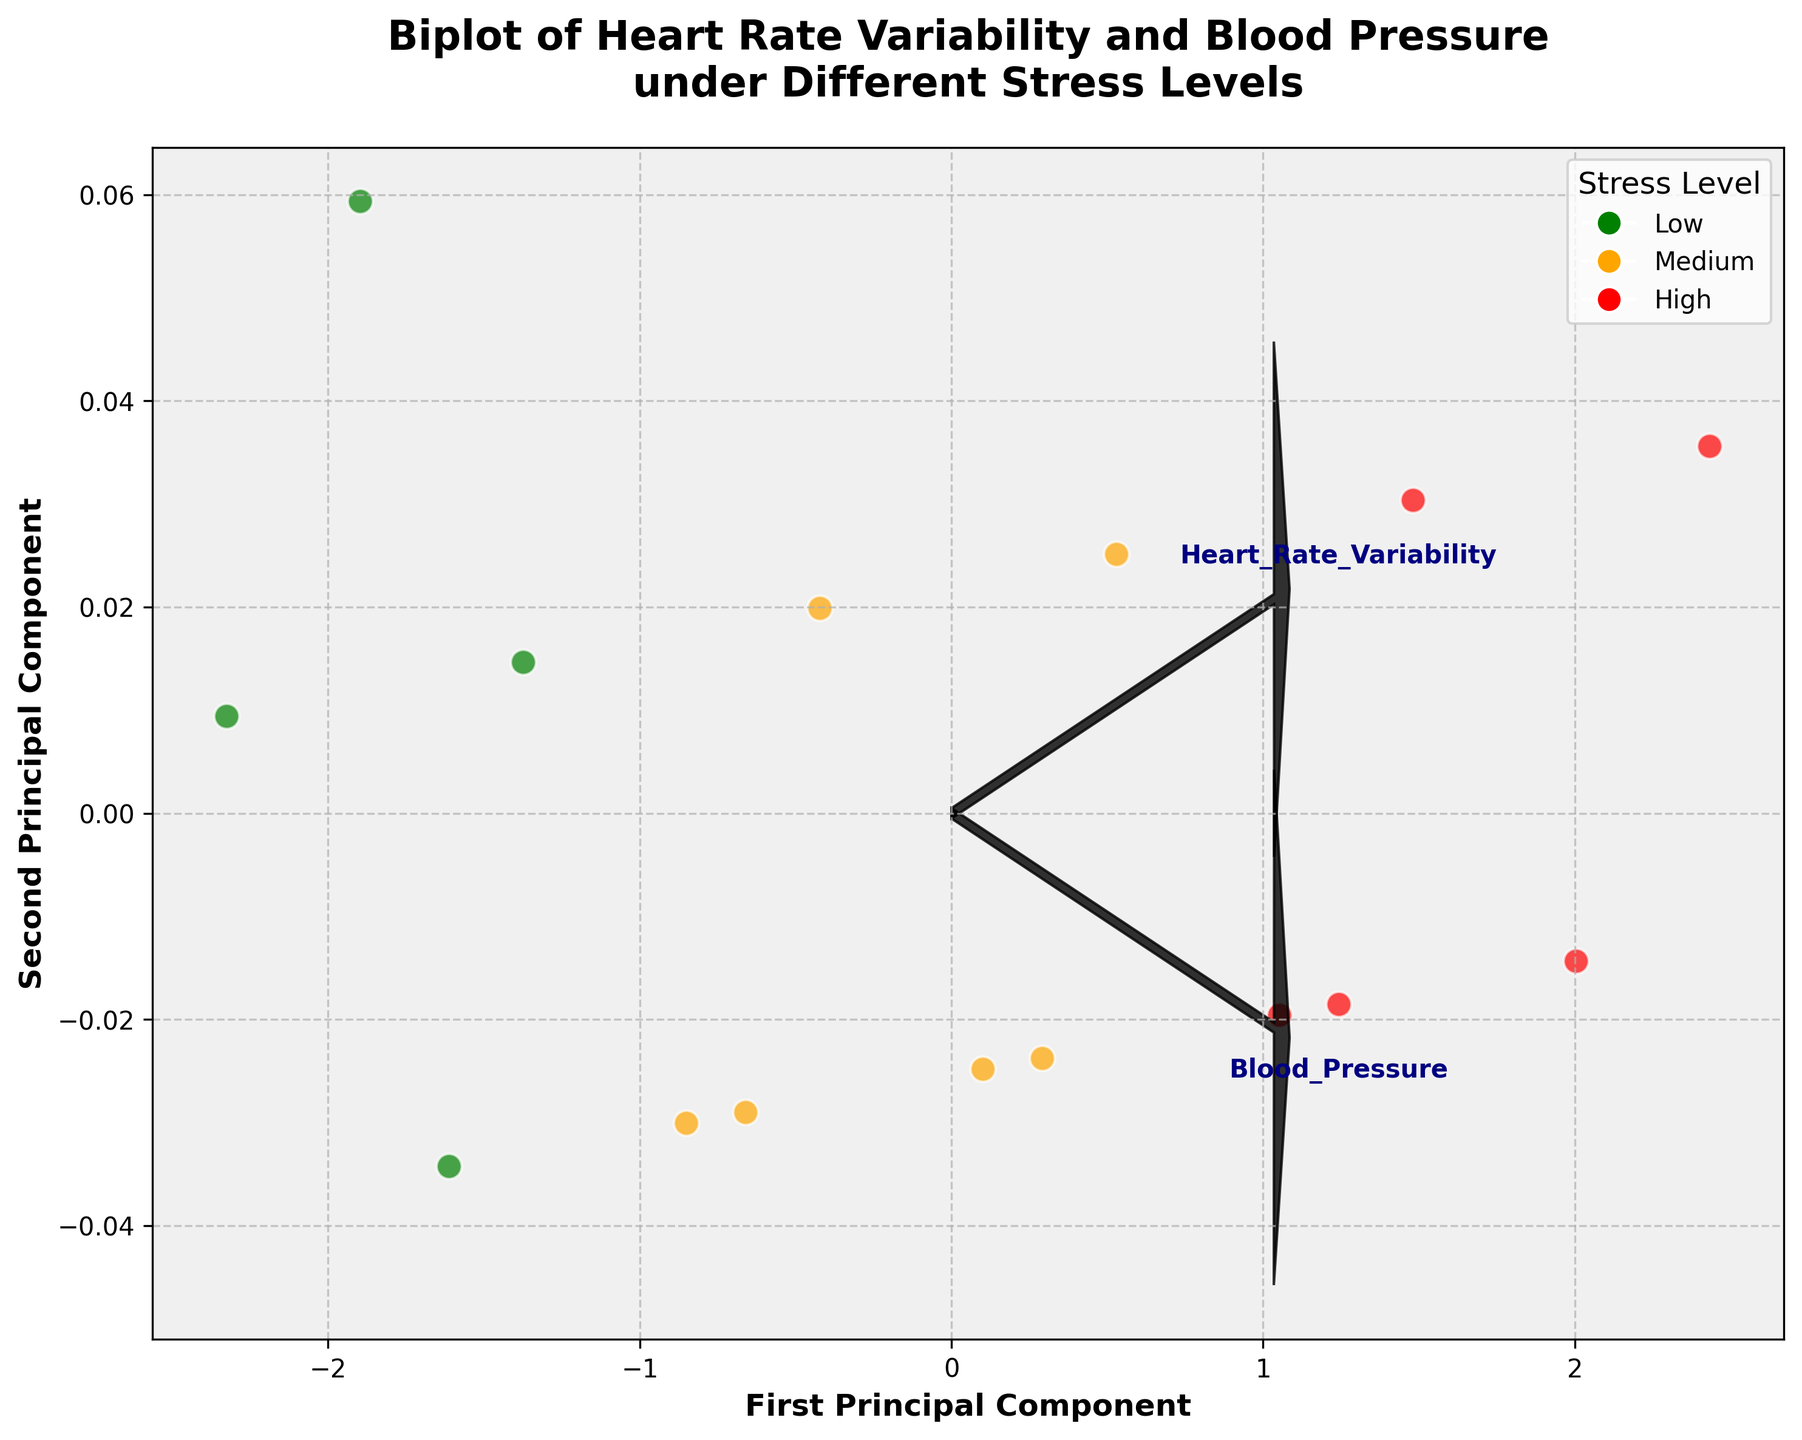What is the title of this biplot? The title is usually located at the top of the biplot and describes what the plot represents. Here, the title is likely to summarize what data the biplot is exploring.
Answer: Biplot of Heart Rate Variability and Blood Pressure under Different Stress Levels What are the axis labels for this biplot? The axis labels are typically found along the x-axis and y-axis, explaining what each axis represents in terms of variables or principal components. Here, they should correspond to the PCA components.
Answer: First Principal Component, Second Principal Component What colors represent the different stress levels in the scatter plot? The colors are used to differentiate the stress levels. By observing the legend, we can see which color corresponds to which stress level.
Answer: green, orange, red How many data points are plotted in total? To find the number of data points, we count each scatter marker present in the plot. Based on the given data, each row corresponds to a unique data point.
Answer: 15 Which feature vectors are represented by arrows in the biplot? The arrows represent the original variables (features) in the biplot, showing how much each feature contributes to the principal components. These are identified by the text labels near the arrows.
Answer: Heart Rate Variability, Blood Pressure How is the blood pressure value determined before applying PCA? Blood pressure values are provided as systolic/diastolic, but for PCA, only the systolic (first number) is used. This transformation simplifies the analysis.
Answer: Systolic value Which stress level has data points with the largest spread along the first principal component? Observe the distribution of points along the first principal component. The spread is determined by the range of values along the x-axis for each stress level.
Answer: High How many vectors or arrows are plotted to represent the features in the biplot? Each feature in the dataset (after standardizing PCA) is represented by an arrow. Check the number of arrows labeled with feature names.
Answer: 2 Which stress level has markers that are least spread out along the second principal component? Look at the distribution of points along the y-axis (second principal component). The level with the smallest range in this dimension has the least spread.
Answer: Low Which feature contributes more to the first principal component, Heart Rate Variability or Blood Pressure? Check the direction and length of the arrows relative to the first principal component. The longer the arrow's projection on the x-axis, the greater the contribution to the first principal component.
Answer: Heart Rate Variability 